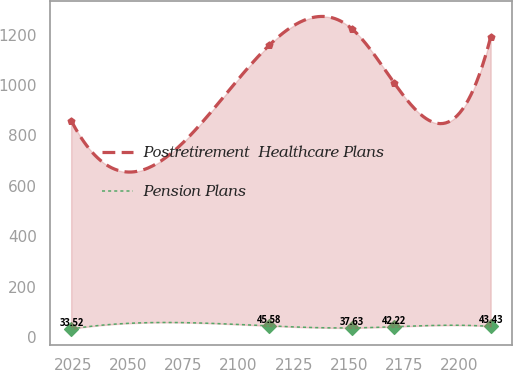<chart> <loc_0><loc_0><loc_500><loc_500><line_chart><ecel><fcel>Postretirement  Healthcare Plans<fcel>Pension Plans<nl><fcel>2024.15<fcel>858.98<fcel>33.52<nl><fcel>2113.87<fcel>1157.85<fcel>45.58<nl><fcel>2151.42<fcel>1221.95<fcel>37.63<nl><fcel>2170.42<fcel>1008.78<fcel>42.22<nl><fcel>2214.18<fcel>1189.9<fcel>43.43<nl></chart> 